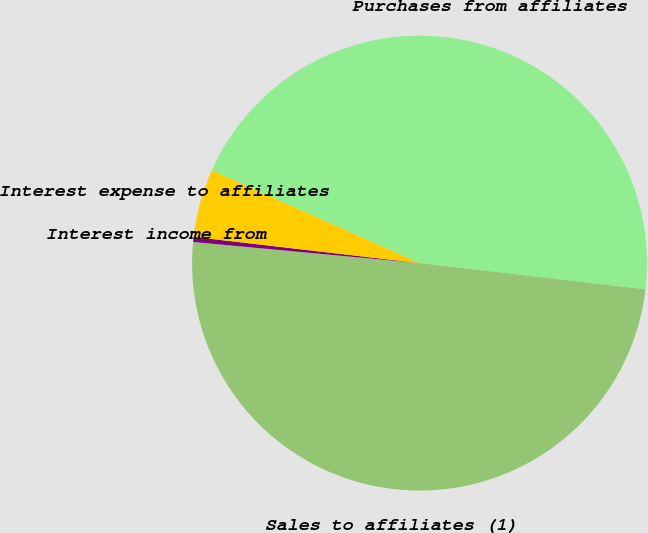Convert chart. <chart><loc_0><loc_0><loc_500><loc_500><pie_chart><fcel>Purchases from affiliates<fcel>Sales to affiliates (1)<fcel>Interest income from<fcel>Interest expense to affiliates<nl><fcel>45.16%<fcel>49.64%<fcel>0.36%<fcel>4.84%<nl></chart> 